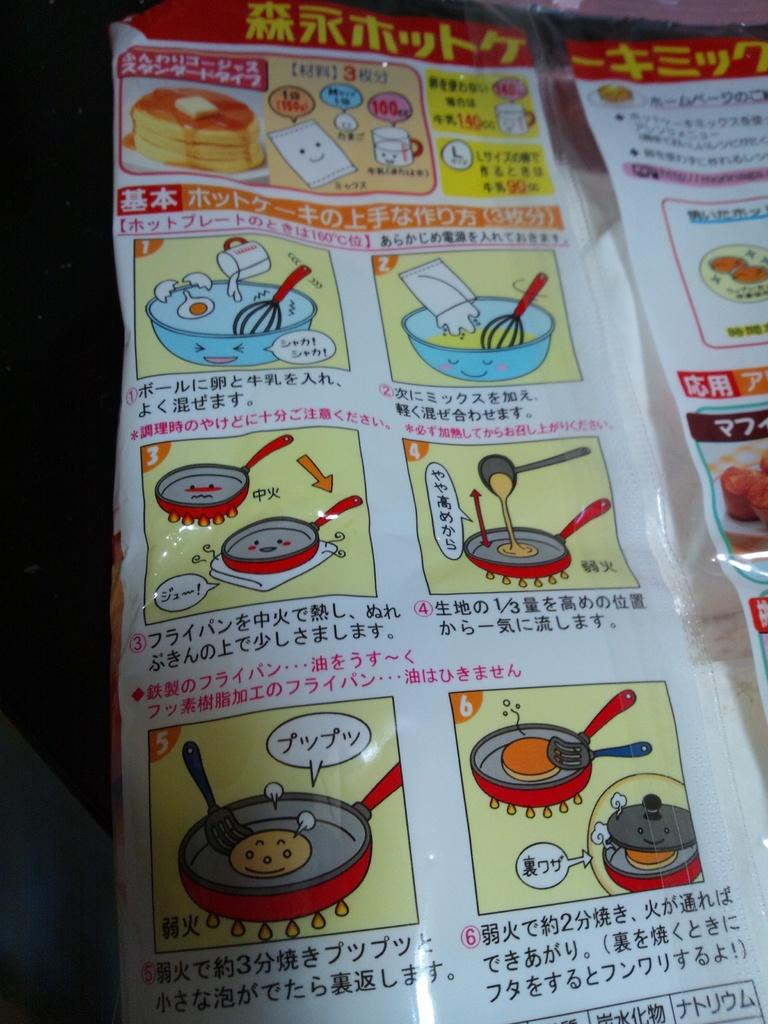What is present in the image? There is a packet in the image. What is inside the packet? The packet contains cooking instructions. How are the cooking instructions presented? The cooking instructions include images and text. How many friends are shown in the image? There are no friends depicted in the image; it features a packet with cooking instructions. What type of feather is used to illustrate the cooking instructions? There is no feather present in the image; the cooking instructions include images and text, but no feathers. 